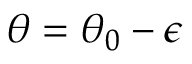<formula> <loc_0><loc_0><loc_500><loc_500>\theta = \theta _ { 0 } - \epsilon</formula> 